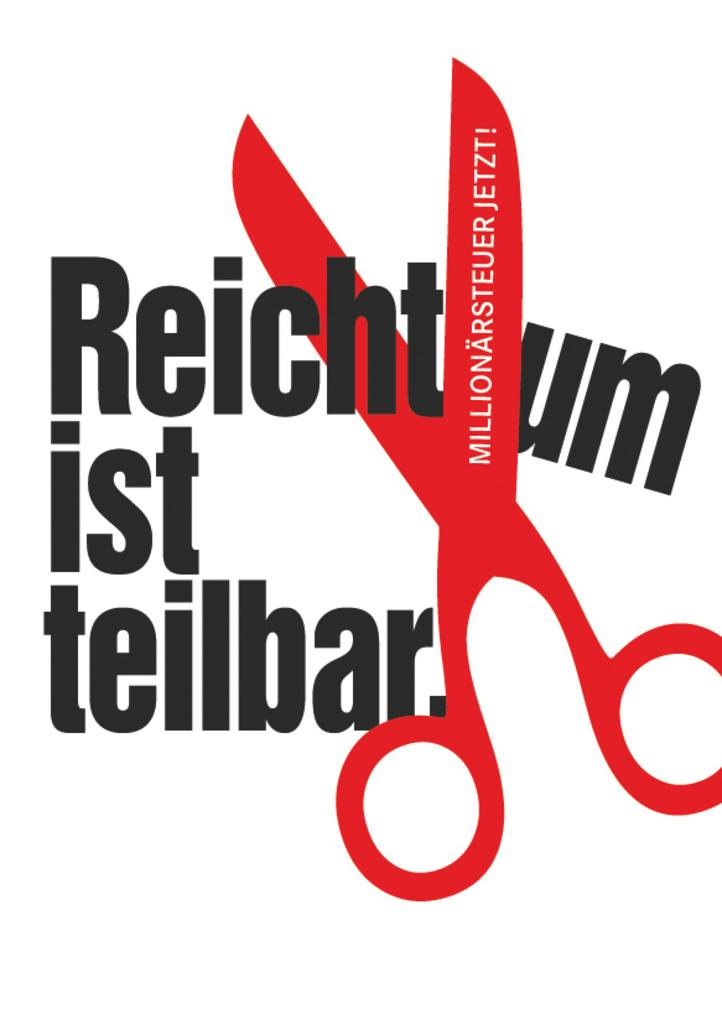What can be seen in the image that is related to writing or text? There are words written in the image. What object is depicted in the image? There is a depiction of a scissor in the image. What is the primary color of the background in the image? The background of the image is white. What is the purpose of the words written in the image? It is not clear from the facts provided what the purpose of the words is, but they are present in the image. How does the sleet affect the scissor in the image? There is no sleet present in the image, so it cannot affect the scissor. What type of sorting is being done with the words in the image? There is no indication of any sorting being done with the words in the image. 